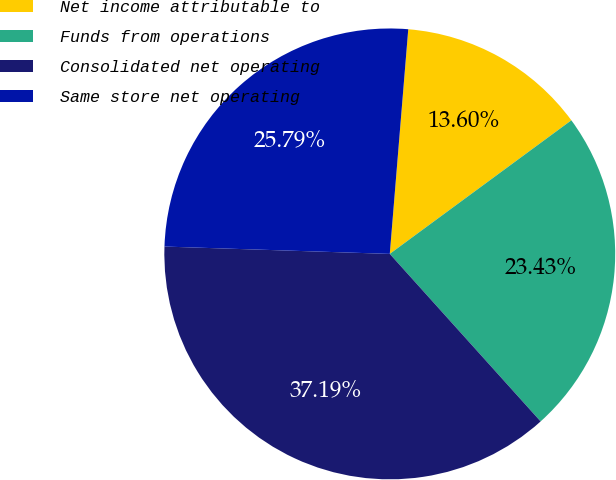<chart> <loc_0><loc_0><loc_500><loc_500><pie_chart><fcel>Net income attributable to<fcel>Funds from operations<fcel>Consolidated net operating<fcel>Same store net operating<nl><fcel>13.6%<fcel>23.43%<fcel>37.19%<fcel>25.79%<nl></chart> 